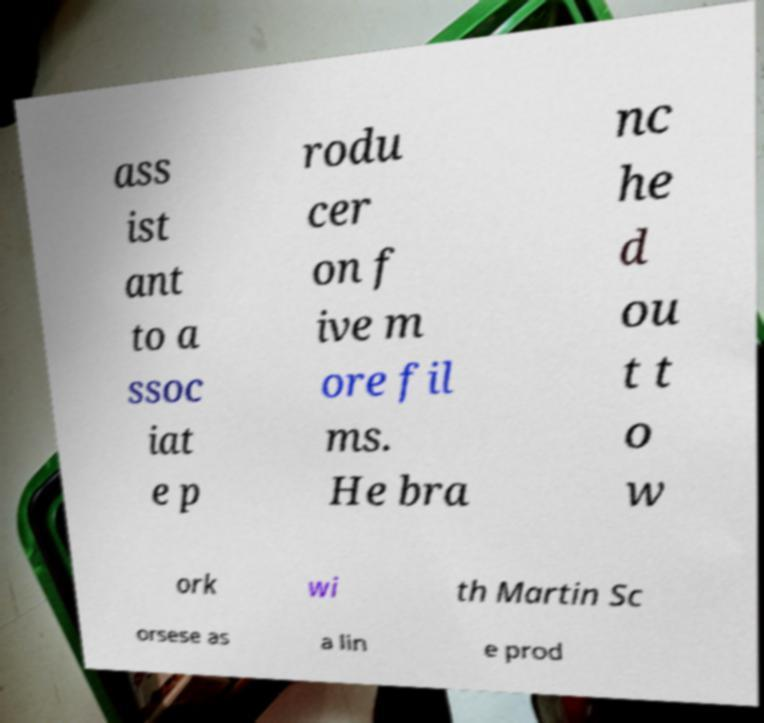Could you extract and type out the text from this image? ass ist ant to a ssoc iat e p rodu cer on f ive m ore fil ms. He bra nc he d ou t t o w ork wi th Martin Sc orsese as a lin e prod 